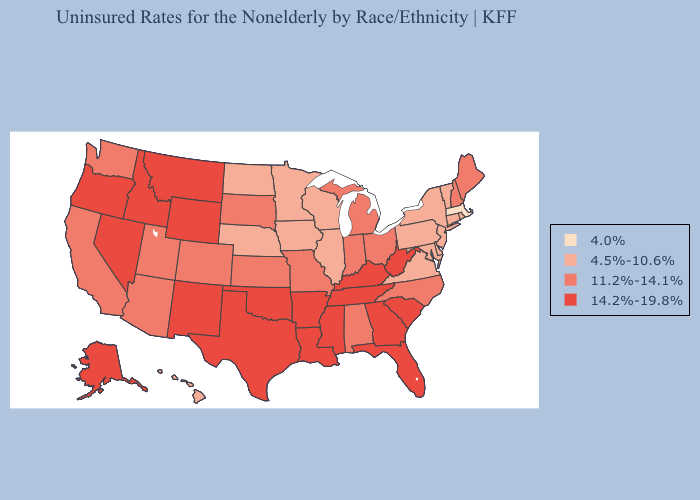Which states have the lowest value in the Northeast?
Concise answer only. Massachusetts. What is the highest value in states that border Mississippi?
Be succinct. 14.2%-19.8%. Does the map have missing data?
Give a very brief answer. No. What is the highest value in the South ?
Answer briefly. 14.2%-19.8%. Name the states that have a value in the range 4.0%?
Short answer required. Massachusetts. Does Ohio have the lowest value in the MidWest?
Be succinct. No. Does Washington have a lower value than Arkansas?
Short answer required. Yes. Does the map have missing data?
Keep it brief. No. What is the value of Illinois?
Answer briefly. 4.5%-10.6%. Name the states that have a value in the range 4.0%?
Quick response, please. Massachusetts. Does Massachusetts have the lowest value in the USA?
Answer briefly. Yes. What is the value of Iowa?
Be succinct. 4.5%-10.6%. How many symbols are there in the legend?
Quick response, please. 4. Among the states that border South Carolina , which have the lowest value?
Keep it brief. North Carolina. 